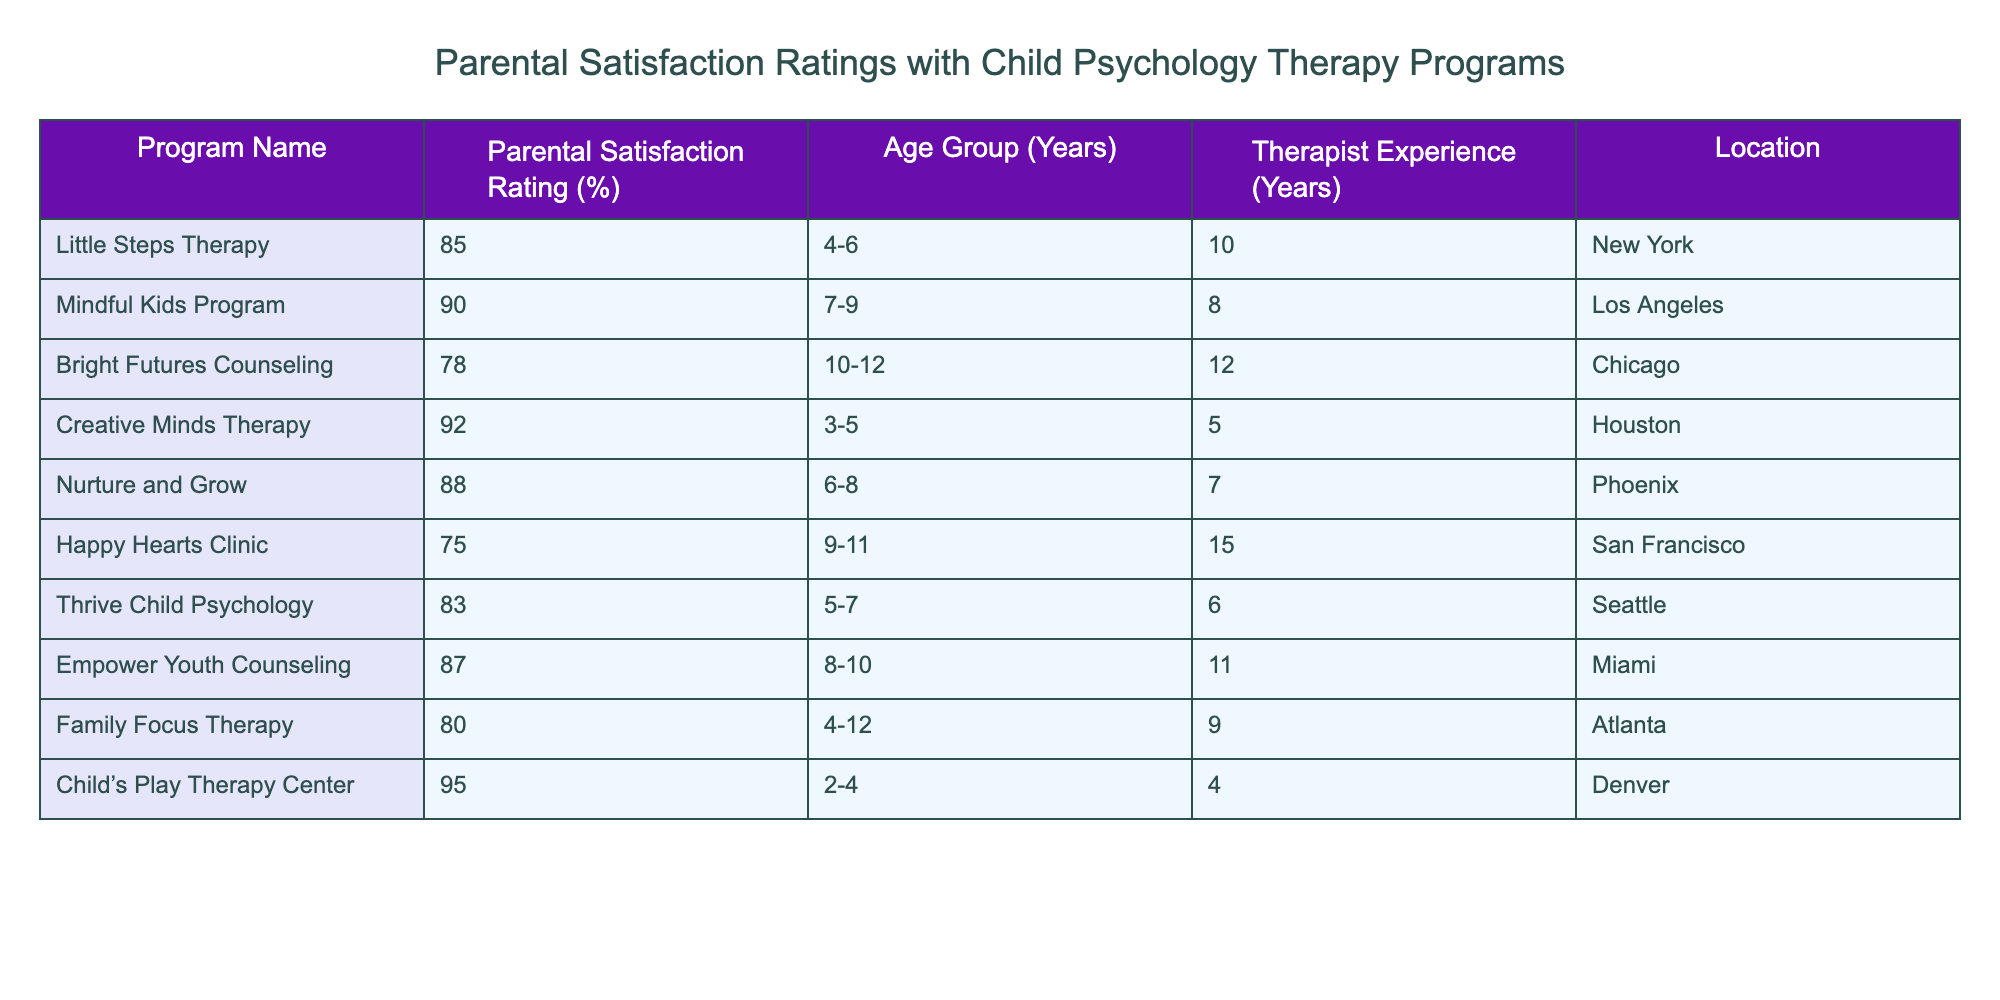What is the Parental Satisfaction Rating for the "Child’s Play Therapy Center"? The table indicates that the Parental Satisfaction Rating for "Child’s Play Therapy Center" is listed under the corresponding column next to the program name. The value is 95%.
Answer: 95% Which therapy program has the highest Parental Satisfaction Rating? By examining each program's rating in the table, we find that "Child’s Play Therapy Center" has the highest rating of 95%.
Answer: Child’s Play Therapy Center What rating does the "Happy Hearts Clinic" program receive? The specific rating for "Happy Hearts Clinic" can be found by looking directly across from the program name in the rating column, which shows it is 75%.
Answer: 75% Is the average Parental Satisfaction Rating for programs located in Phoenix greater than 85%? The rating for "Nurture and Grow" (88%) is the only one from Phoenix. Therefore, the average is 88%, which is indeed greater than 85%.
Answer: Yes What is the total Parental Satisfaction Rating of all programs in the age group 4-6? From the table, "Little Steps Therapy" (85%) and "Family Focus Therapy" (80%) fall into this age group. Adding these values gives 85 + 80 = 165.
Answer: 165 Which program has the lowest satisfaction rating among those servicing the 9-11 age group? The relevant programs for the age group 9-11 are "Happy Hearts Clinic" (75%) and "Mindful Kids Program" (90%). Comparing the two ratings shows that "Happy Hearts Clinic" has the lowest rating of 75%.
Answer: Happy Hearts Clinic Does the "Creative Minds Therapy" program have a therapist with more than 10 years of experience? The table lists "Creative Minds Therapy" with a therapist experience of 5 years, which is less than 10 years.
Answer: No What is the difference in satisfaction rating between the highest-rated and lowest-rated programs? The highest-rated program is "Child’s Play Therapy Center" (95%), and the lowest-rated is "Happy Hearts Clinic" (75%). The difference is calculated as 95 - 75 = 20.
Answer: 20 What can you say about the average satisfaction rating for programs with therapists who have at least 10 years of experience? The relevant programs are "Bright Futures Counseling" (78%), "Happy Hearts Clinic" (75%), and "Empower Youth Counseling" (87%). The average is calculated as (78 + 75 + 87) / 3 = 80.
Answer: 80 